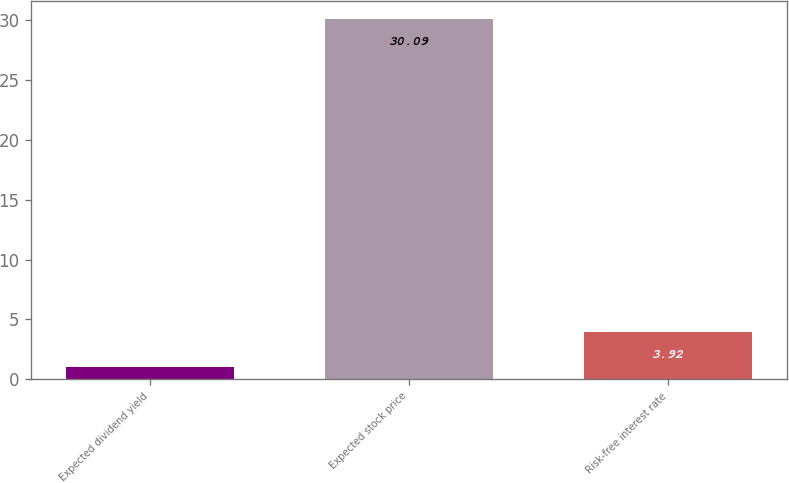<chart> <loc_0><loc_0><loc_500><loc_500><bar_chart><fcel>Expected dividend yield<fcel>Expected stock price<fcel>Risk-free interest rate<nl><fcel>1.01<fcel>30.09<fcel>3.92<nl></chart> 